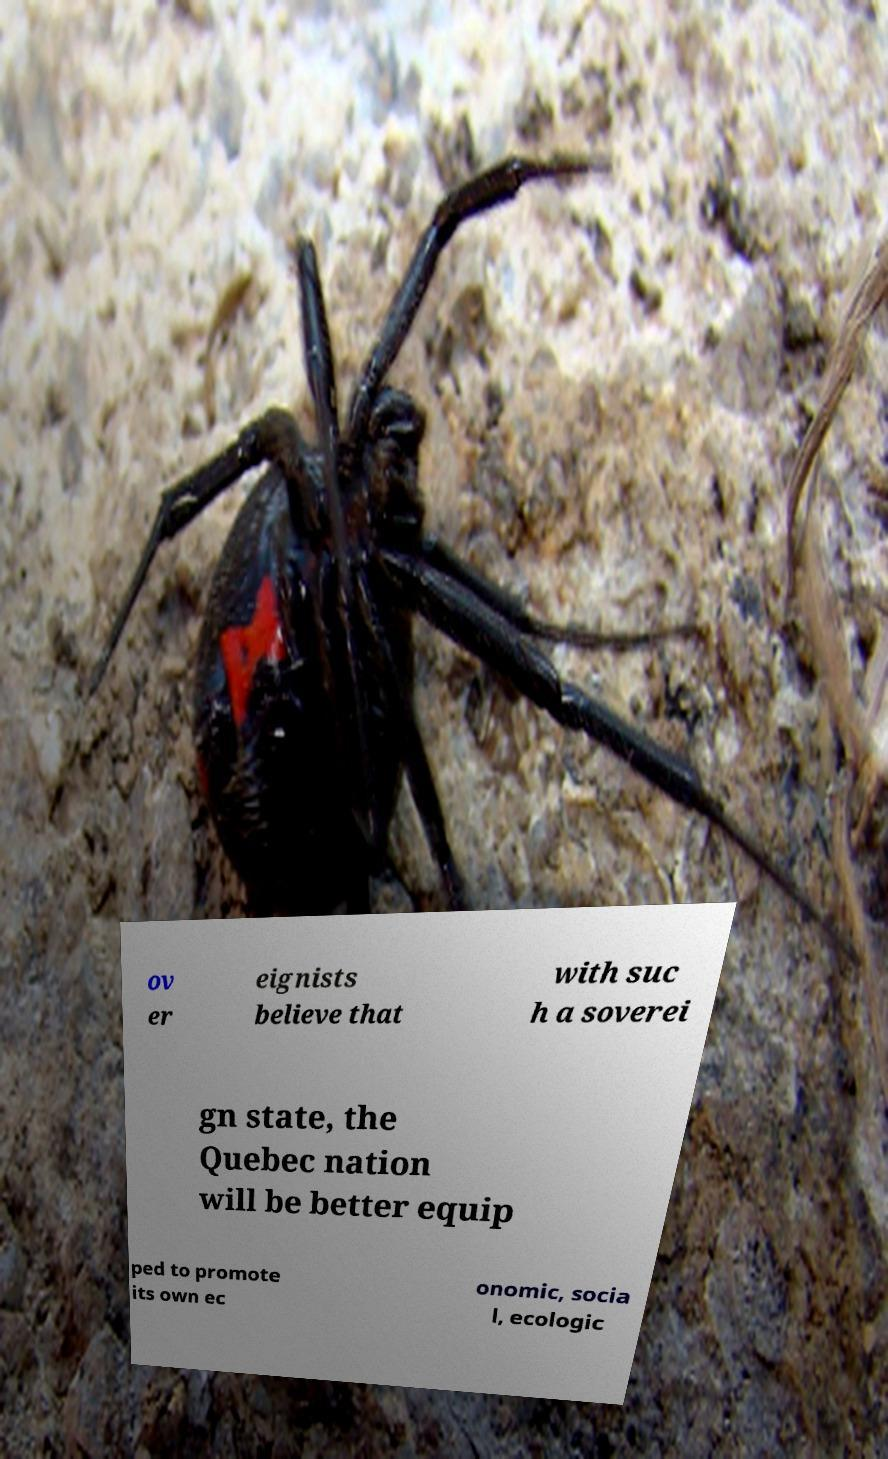Please read and relay the text visible in this image. What does it say? ov er eignists believe that with suc h a soverei gn state, the Quebec nation will be better equip ped to promote its own ec onomic, socia l, ecologic 